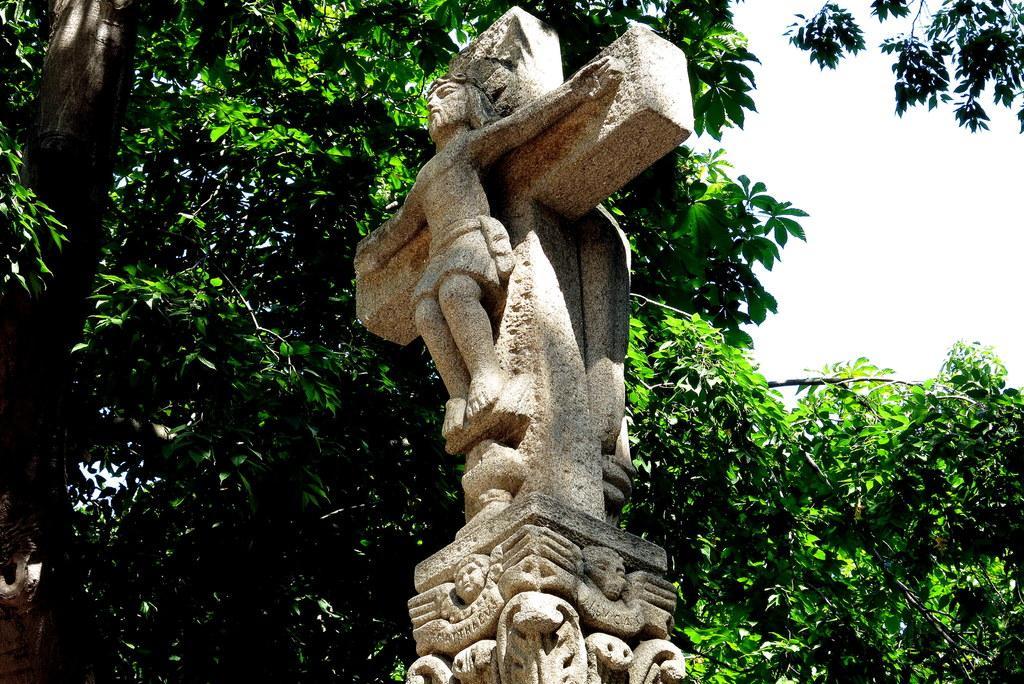In one or two sentences, can you explain what this image depicts? In this image there is a sculpture. Behind it there are trees. In the top right there is the sky. 